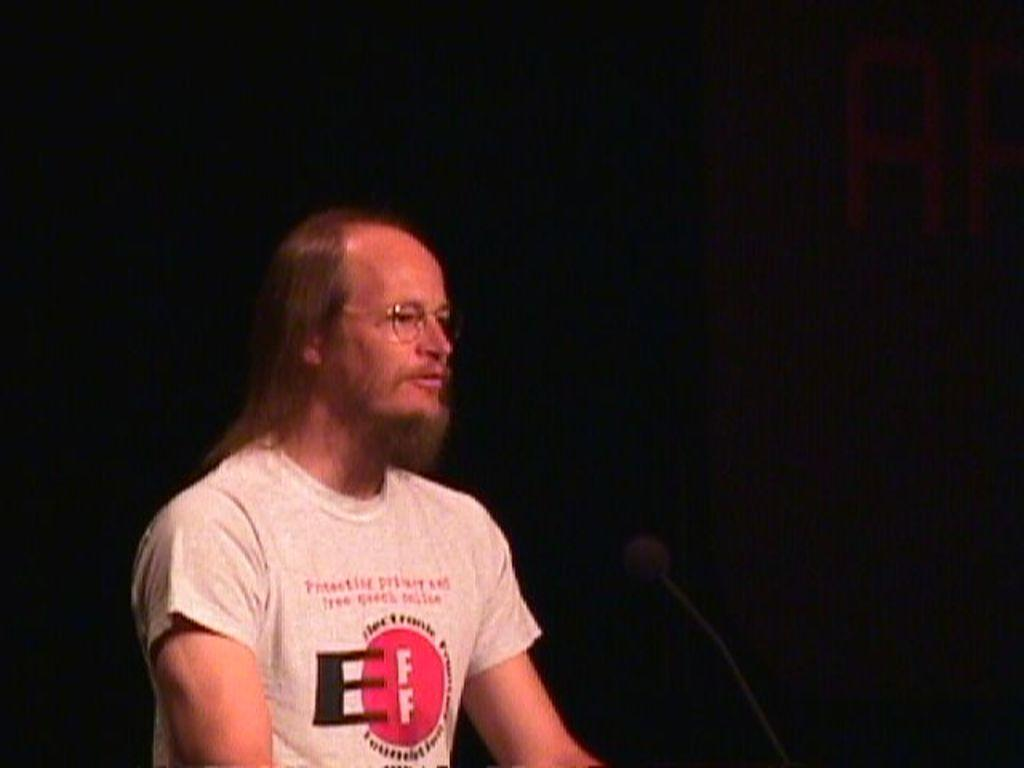What is the main subject of the image? There is a person in the image. What can be observed about the person's clothing? The person is wearing a t-shirt with white, red, and black colors. What object is in front of the person? There is a microphone in front of the person. What color is the background of the image? The background of the image is black. Can you see any squirrels or goats in the image? No, there are no squirrels or goats present in the image. What does the person regret in the image? There is no indication of regret in the image, as it only shows a person with a microphone in front of them. 